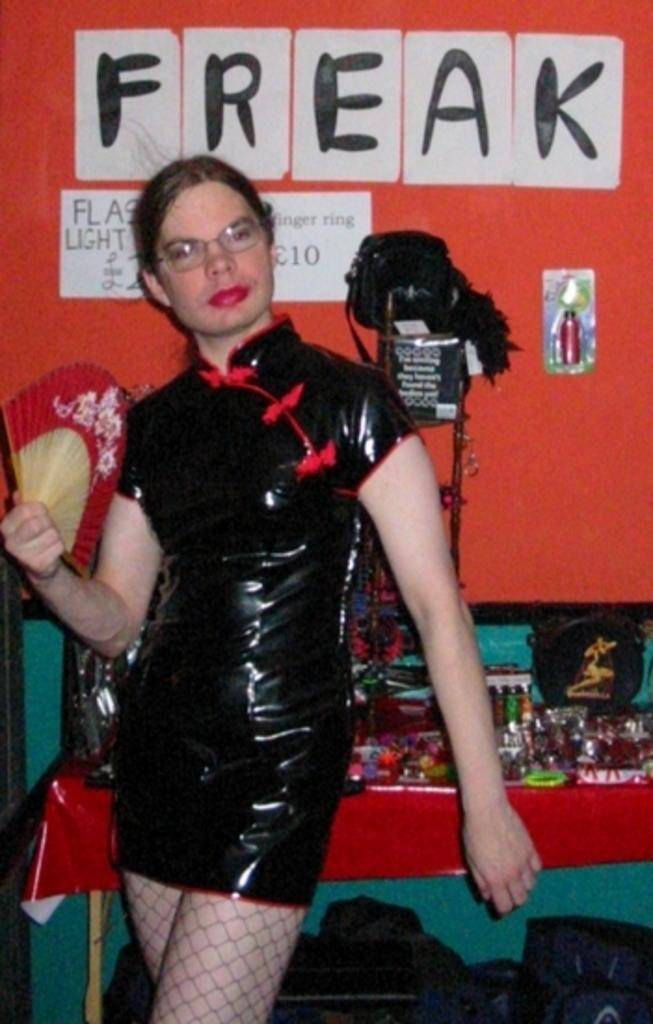Who is the main subject in the image? There is a lady in the image. Where is the lady positioned in the image? The lady is standing on the left side of the image. What is located behind the lady? There is a table behind the lady. What can be seen at the top side of the image? There are posters at the top side of the image. What is the fifth object in the image? There is no mention of a fifth object in the image, as only four objects are described in the facts provided. 